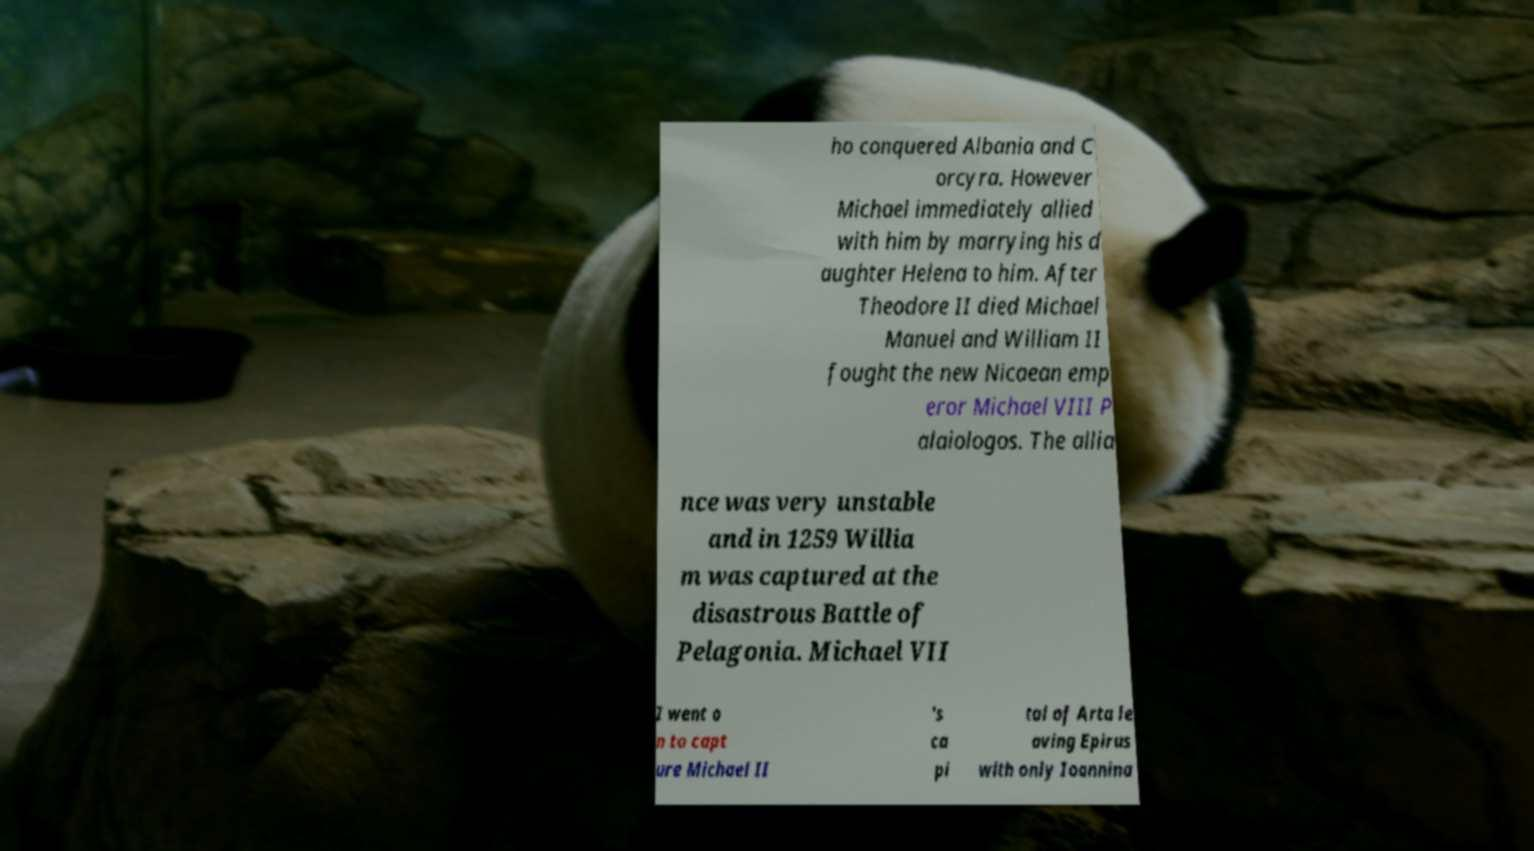I need the written content from this picture converted into text. Can you do that? ho conquered Albania and C orcyra. However Michael immediately allied with him by marrying his d aughter Helena to him. After Theodore II died Michael Manuel and William II fought the new Nicaean emp eror Michael VIII P alaiologos. The allia nce was very unstable and in 1259 Willia m was captured at the disastrous Battle of Pelagonia. Michael VII I went o n to capt ure Michael II 's ca pi tal of Arta le aving Epirus with only Ioannina 